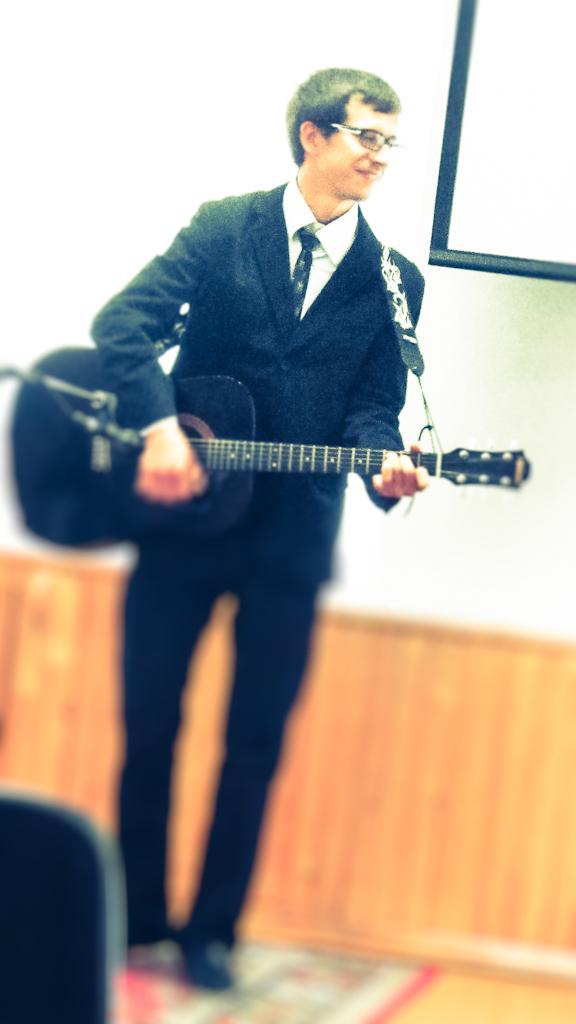Can you describe this image briefly? This is a picture taken in a room, a boy in black blazer was holding a guitar and the man is standing on the floor. Behind the man there is a wall and a projector screen. 